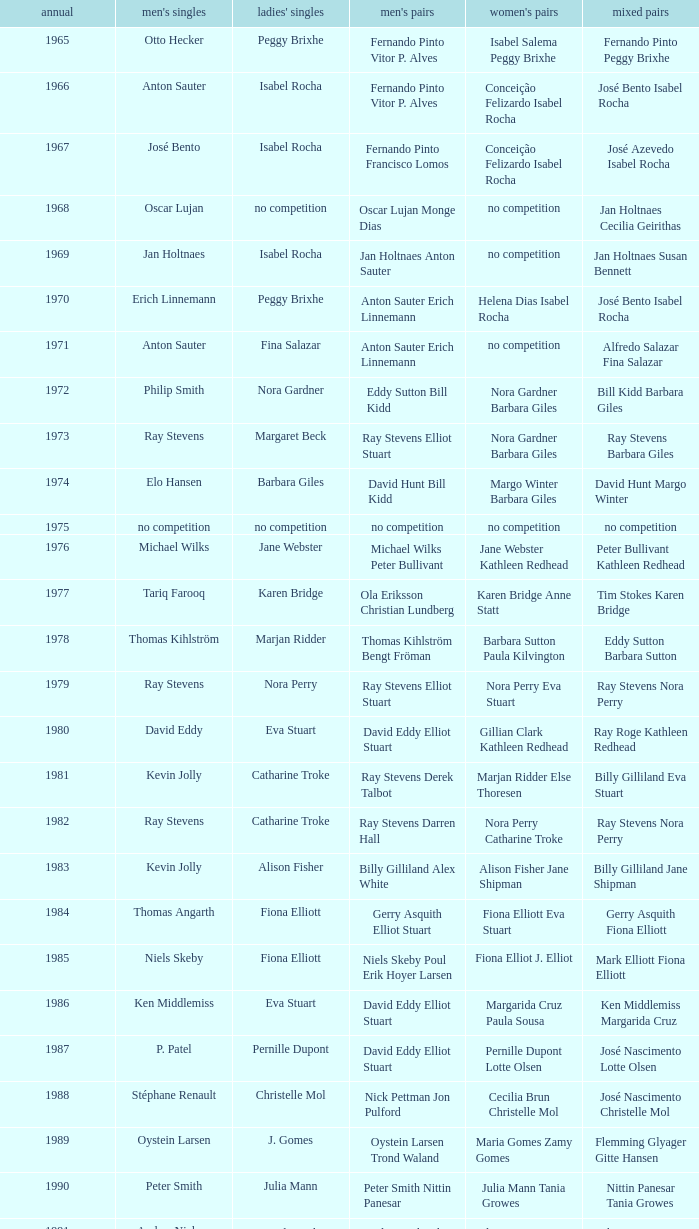Which women's doubles happened after 1987 and a women's single of astrid van der knaap? Elena Denisova Marina Yakusheva. 